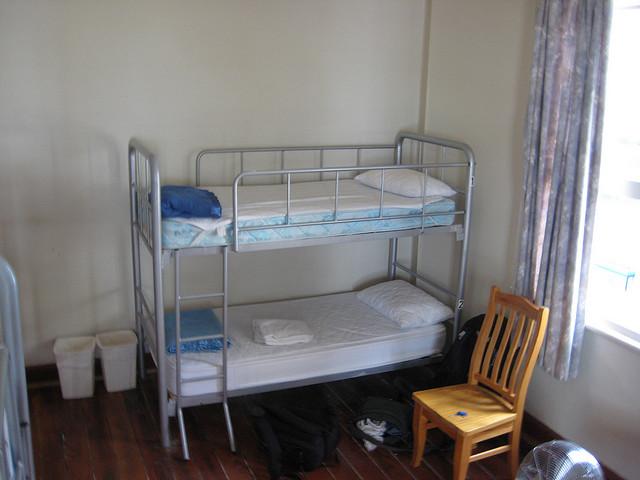Why are there rails on the top bunk?
Quick response, please. So people don't fall out while sleeping. How many towels are on the bed?
Keep it brief. 1. What is the room in the photo?
Concise answer only. Bedroom. Is this most likely a hotel or residence?
Quick response, please. Residence. Is this a bunk bed?
Short answer required. Yes. Why are there two trash cans?
Concise answer only. For 2 people. 